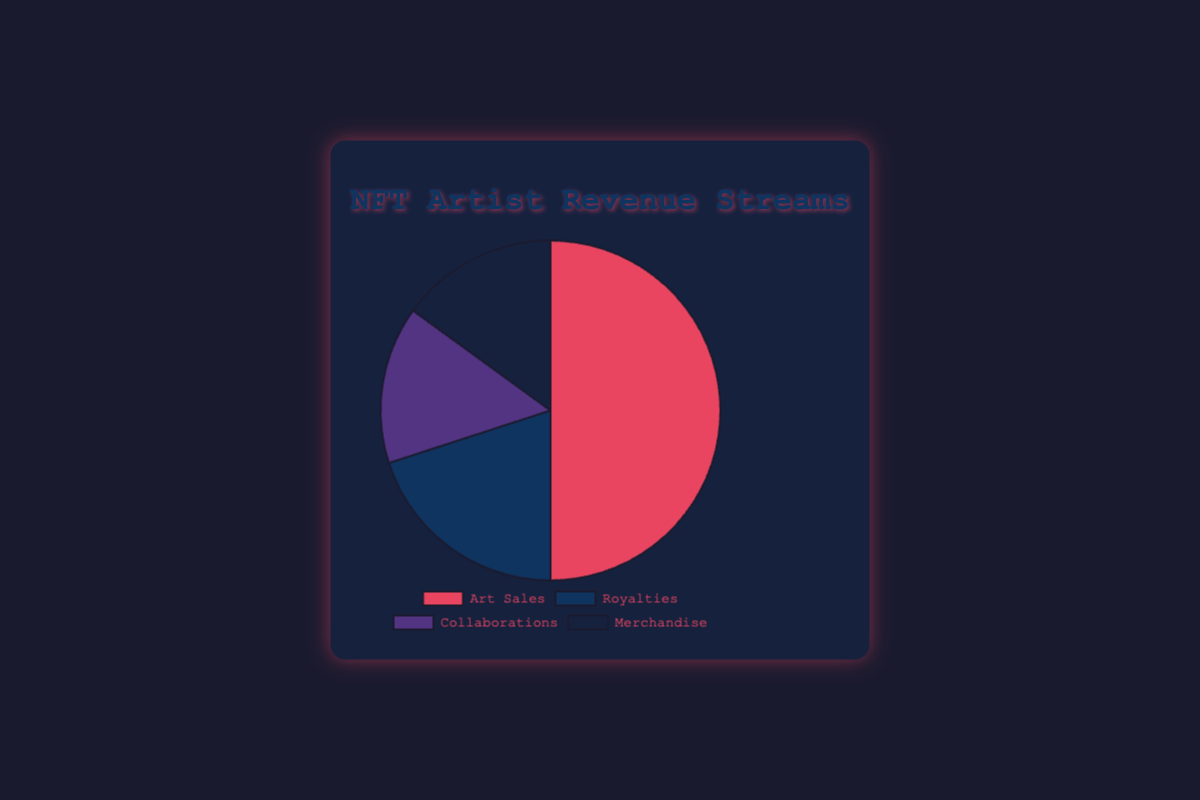What percentage of total revenue streams does Art Sales constitute? Art Sales takes up 50% of the total revenue, as directly indicated by the pie chart's label for Art Sales.
Answer: 50% Which revenue stream contributes the least to the total revenue? Both Collaborations and Merchandise each contribute 15% to the total revenue, as indicated by the pie chart's labels for these categories.
Answer: Collaborations and Merchandise How much more percentage does Art Sales contribute compared to Royalties? Art Sales contributes 50%, while Royalties contribute 20%. The difference is 50% - 20% = 30%.
Answer: 30% What is the combined percentage of Collaborations and Merchandise? Collaborations and Merchandise each contribute 15%. Adding them together: 15% + 15% = 30%.
Answer: 30% Is Royalties' contribution more or less than the combined contribution of Collaborations and Merchandise? Royalties contribute 20%, while Collaborations and Merchandise together contribute 15% + 15% = 30%. Therefore, Royalties' contribution is less.
Answer: Less Which segment is represented by the red color in the pie chart? The red color represents Art Sales, as seen from the chart visual.
Answer: Art Sales Are Art Sales and Merchandise combined greater than 70% of the total revenue? Art Sales is 50% and Merchandise is 15%. Adding them: 50% + 15% = 65%, which is less than 70%.
Answer: No What is the average percentage contribution of all revenue streams? The percentages are 50%, 20%, 15%, and 15%. The sum is 50 + 20 + 15 + 15 = 100. The average is 100 / 4 = 25%.
Answer: 25% If the revenue from Merchandise doubled, what would be its new percentage? The current percentage for Merchandise is 15%. If it doubles, it would be 15% * 2 = 30%.
Answer: 30% Comparing Art Sales and Collaborations, how many times greater is the contribution from Art Sales? Art Sales contributes 50%, and Collaborations contribute 15%. The ratio is 50% / 15% = 3.33 times.
Answer: 3.33 times 